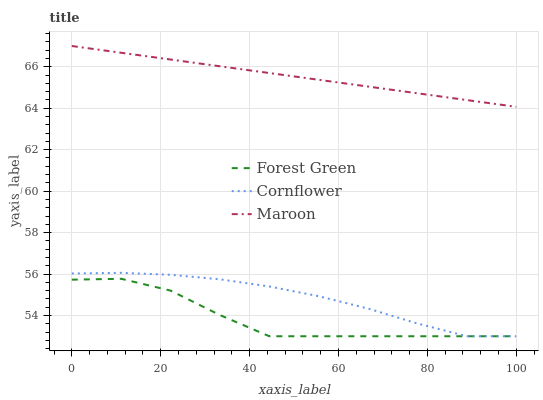Does Maroon have the minimum area under the curve?
Answer yes or no. No. Does Forest Green have the maximum area under the curve?
Answer yes or no. No. Is Forest Green the smoothest?
Answer yes or no. No. Is Maroon the roughest?
Answer yes or no. No. Does Maroon have the lowest value?
Answer yes or no. No. Does Forest Green have the highest value?
Answer yes or no. No. Is Cornflower less than Maroon?
Answer yes or no. Yes. Is Maroon greater than Forest Green?
Answer yes or no. Yes. Does Cornflower intersect Maroon?
Answer yes or no. No. 